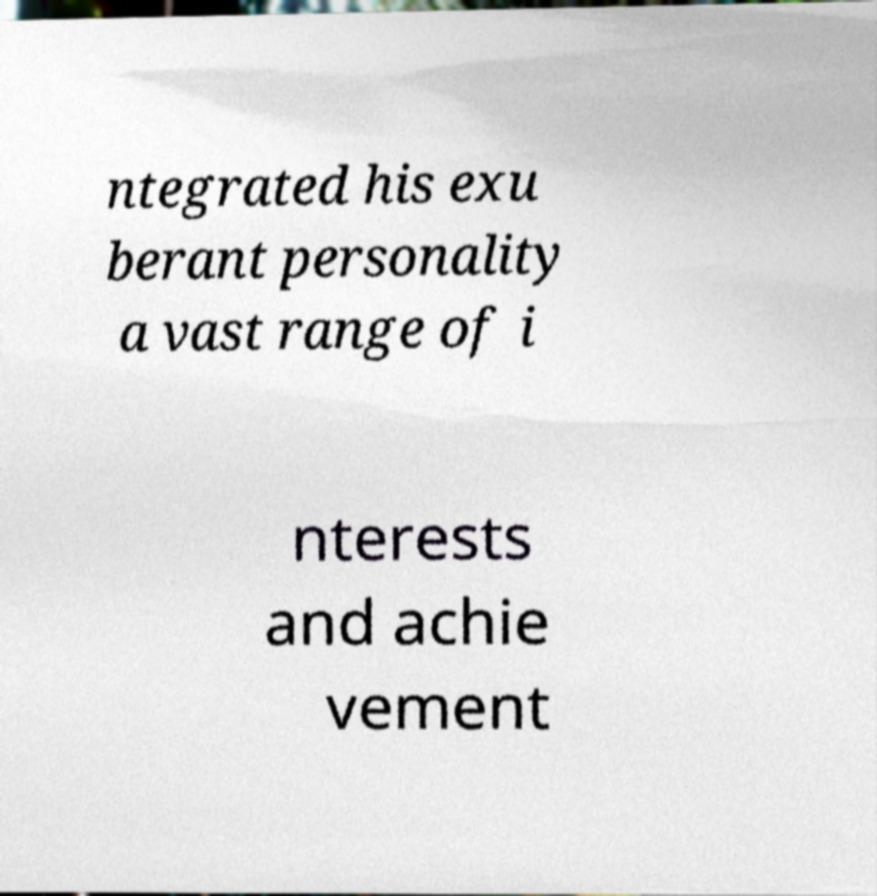For documentation purposes, I need the text within this image transcribed. Could you provide that? ntegrated his exu berant personality a vast range of i nterests and achie vement 